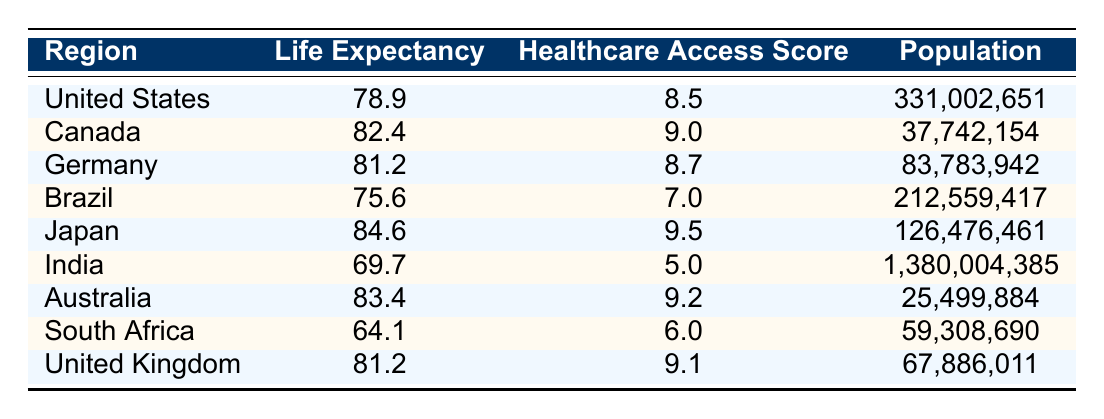What is the life expectancy in Canada? From the table, the life expectancy under the "Canada" row is specified as 82.4 years.
Answer: 82.4 Which region has the highest healthcare access score? Looking at the healthcare access scores, Japan has the highest score at 9.5.
Answer: Japan Is the life expectancy in India higher than in Brazil? The life expectancy in India is 69.7 years, while in Brazil it is 75.6 years. Since 69.7 is less than 75.6, the answer is no.
Answer: No What is the difference in life expectancy between the United States and the United Kingdom? The life expectancy in the United States is 78.9 years and in the United Kingdom it is 81.2 years. The difference is 81.2 - 78.9 = 2.3 years.
Answer: 2.3 What is the average life expectancy of the regions listed in this table? To calculate the average, we sum the life expectancies: 78.9 + 82.4 + 81.2 + 75.6 + 84.6 + 69.7 + 83.4 + 64.1 + 81.2 =  81.1. There are 9 regions, so the average is 730.1 / 9 = 81.1.
Answer: 81.1 Does Australia have a better life expectancy compared to South Africa? Australia has a life expectancy of 83.4 years, while South Africa's is 64.1 years. Since 83.4 is greater than 64.1, the answer is yes.
Answer: Yes What is the population of Japan? The population listed for Japan in the table is 126,476,461.
Answer: 126,476,461 Which region has a healthcare access score below 7? In the table, India has a healthcare access score of 5.0, which is below 7.
Answer: India What is the combined life expectancy of Germany and Canada? Germany's life expectancy is 81.2 years and Canada's is 82.4 years. The combined life expectancy is 81.2 + 82.4 = 163.6 years.
Answer: 163.6 